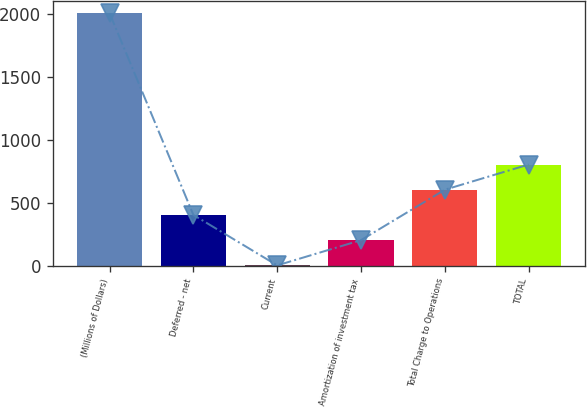Convert chart. <chart><loc_0><loc_0><loc_500><loc_500><bar_chart><fcel>(Millions of Dollars)<fcel>Deferred - net<fcel>Current<fcel>Amortization of investment tax<fcel>Total Charge to Operations<fcel>TOTAL<nl><fcel>2008<fcel>404<fcel>3<fcel>203.5<fcel>604.5<fcel>805<nl></chart> 